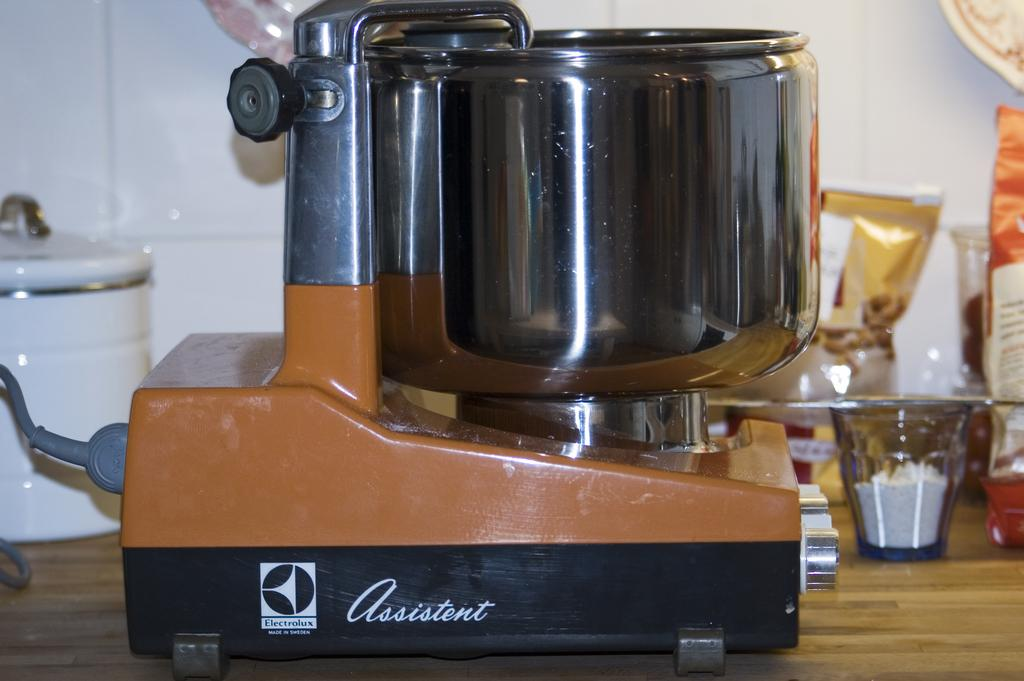Provide a one-sentence caption for the provided image. A machine for food preparation is imprinted with the name "assistent" on the side. 